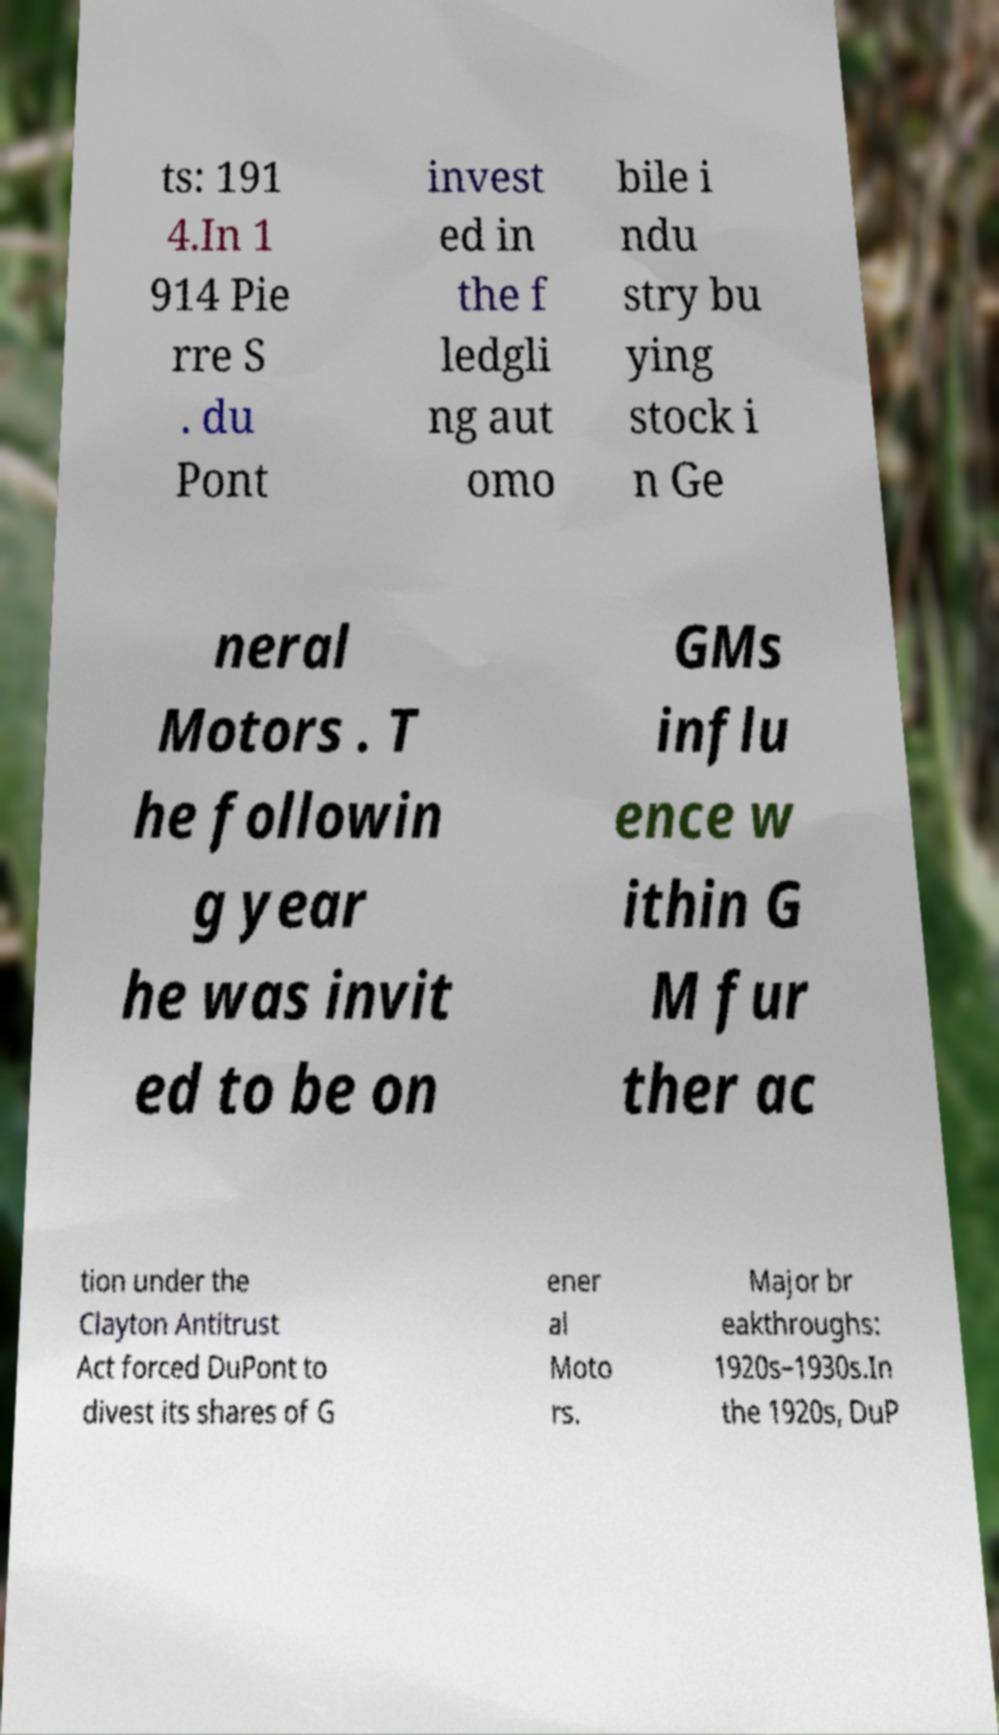Can you read and provide the text displayed in the image?This photo seems to have some interesting text. Can you extract and type it out for me? ts: 191 4.In 1 914 Pie rre S . du Pont invest ed in the f ledgli ng aut omo bile i ndu stry bu ying stock i n Ge neral Motors . T he followin g year he was invit ed to be on GMs influ ence w ithin G M fur ther ac tion under the Clayton Antitrust Act forced DuPont to divest its shares of G ener al Moto rs. Major br eakthroughs: 1920s–1930s.In the 1920s, DuP 